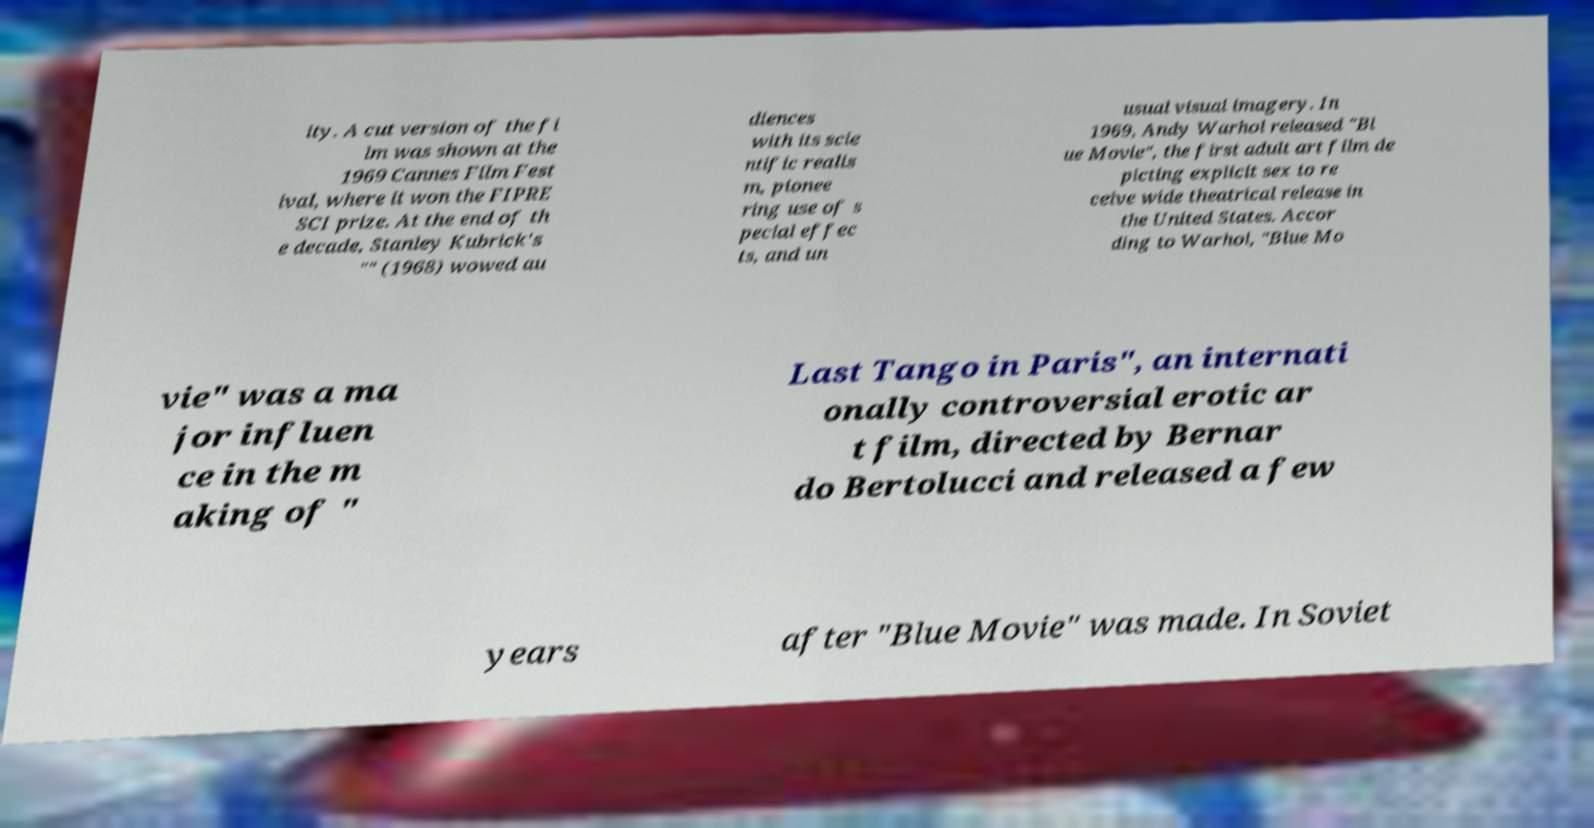Please read and relay the text visible in this image. What does it say? ity. A cut version of the fi lm was shown at the 1969 Cannes Film Fest ival, where it won the FIPRE SCI prize. At the end of th e decade, Stanley Kubrick's "" (1968) wowed au diences with its scie ntific realis m, pionee ring use of s pecial effec ts, and un usual visual imagery. In 1969, Andy Warhol released "Bl ue Movie", the first adult art film de picting explicit sex to re ceive wide theatrical release in the United States. Accor ding to Warhol, "Blue Mo vie" was a ma jor influen ce in the m aking of " Last Tango in Paris", an internati onally controversial erotic ar t film, directed by Bernar do Bertolucci and released a few years after "Blue Movie" was made. In Soviet 